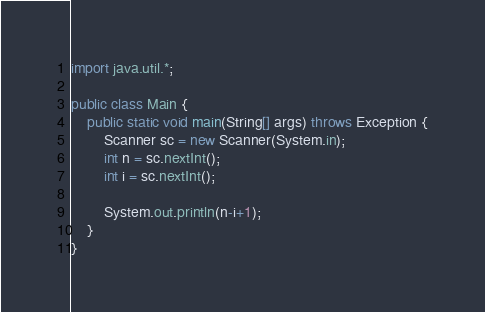<code> <loc_0><loc_0><loc_500><loc_500><_Java_>import java.util.*;

public class Main {
    public static void main(String[] args) throws Exception {
        Scanner sc = new Scanner(System.in);
        int n = sc.nextInt();
        int i = sc.nextInt();
        
        System.out.println(n-i+1);
    }
}
</code> 